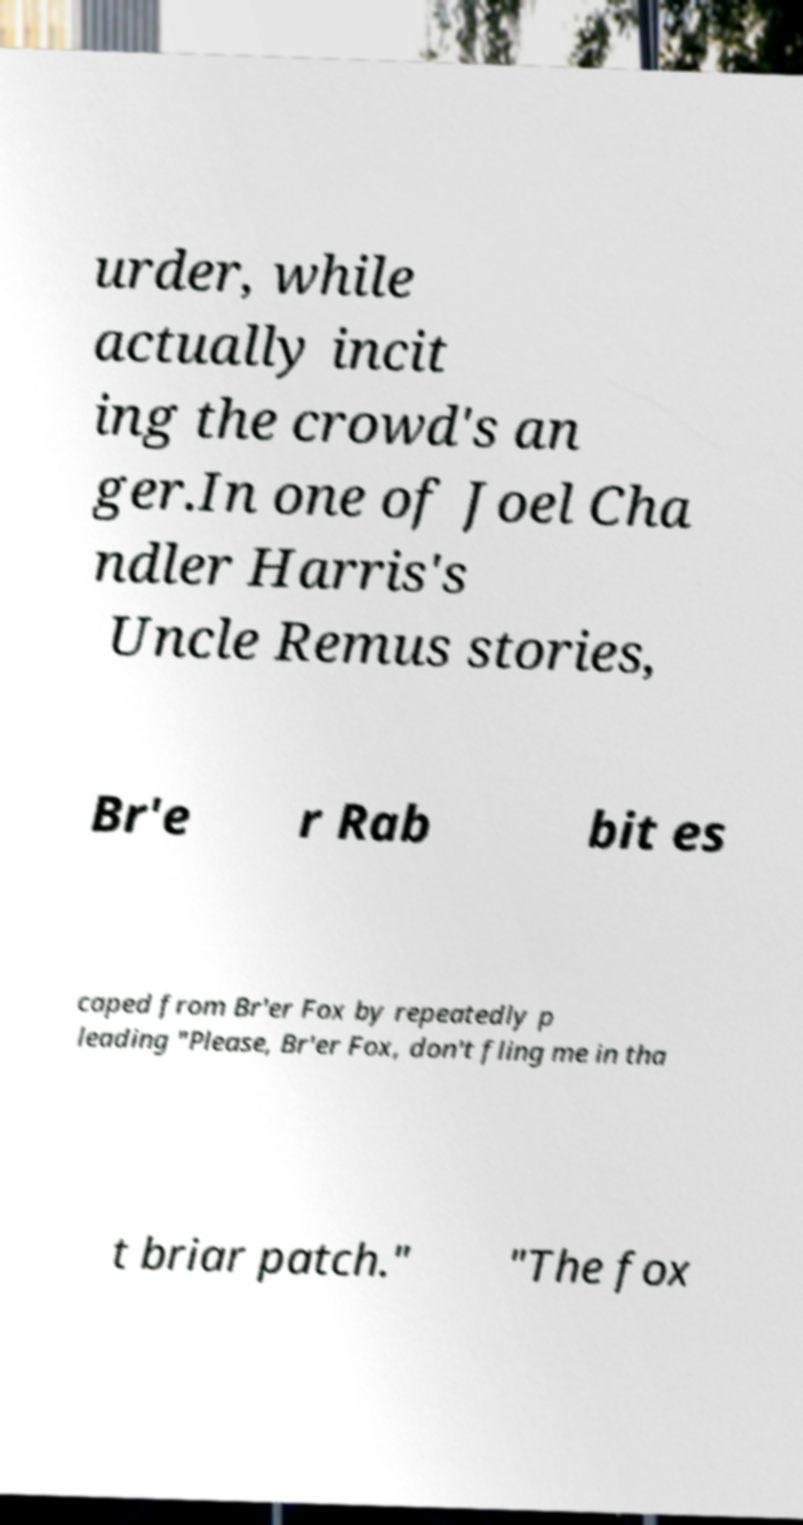Could you extract and type out the text from this image? urder, while actually incit ing the crowd's an ger.In one of Joel Cha ndler Harris's Uncle Remus stories, Br'e r Rab bit es caped from Br'er Fox by repeatedly p leading "Please, Br'er Fox, don't fling me in tha t briar patch." "The fox 